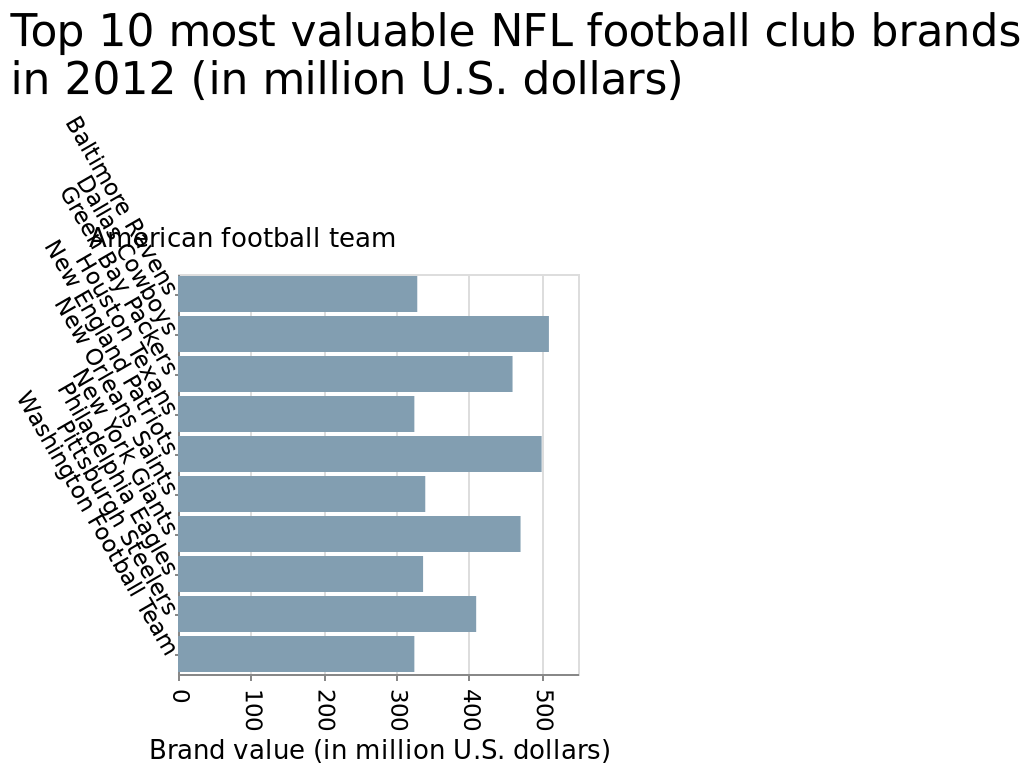<image>
What is the average brand value of all the NFL football clubs?  The average brand value of all the NFL football clubs cannot be determined based on the given information. What does the x-axis measure?  The x-axis measures the brand value in million U.S. dollars. In what year were the brand values represented?  The brand values represented in the bar plot are for the year 2012. Can the average brand value of all the NFL football clubs be determined based on the given information? No. The average brand value of all the NFL football clubs cannot be determined based on the given information. 